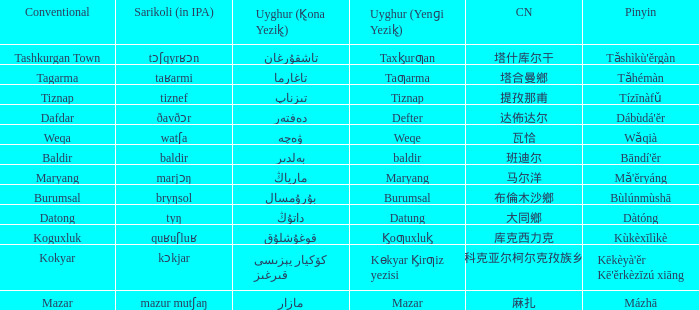Name the uyghur for  瓦恰 ۋەچە. Could you parse the entire table? {'header': ['Conventional', 'Sarikoli (in IPA)', 'Uyghur (K̢ona Yezik̢)', 'Uyghur (Yenɡi Yezik̢)', 'CN', 'Pinyin'], 'rows': [['Tashkurgan Town', 'tɔʃqyrʁɔn', 'تاشقۇرغان', 'Taxk̡urƣan', '塔什库尔干', "Tǎshìkù'ěrgàn"], ['Tagarma', 'taʁarmi', 'تاغارما', 'Taƣarma', '塔合曼鄉', 'Tǎhémàn'], ['Tiznap', 'tiznef', 'تىزناپ', 'Tiznap', '提孜那甫', 'Tízīnàfǔ'], ['Dafdar', 'ðavðɔr', 'دەفتەر', 'Defter', '达佈达尔', "Dábùdá'ĕr"], ['Weqa', 'watʃa', 'ۋەچە', 'Weqe', '瓦恰', 'Wǎqià'], ['Baldir', 'baldir', 'بەلدىر', 'baldir', '班迪尔', "Bāndí'ĕr"], ['Maryang', 'marjɔŋ', 'مارياڭ', 'Maryang', '马尔洋', "Mǎ'ĕryáng"], ['Burumsal', 'bryŋsol', 'بۇرۇمسال', 'Burumsal', '布倫木沙鄉', 'Bùlúnmùshā'], ['Datong', 'tyŋ', 'داتۇڭ', 'Datung', '大同鄉', 'Dàtóng'], ['Koguxluk', 'quʁuʃluʁ', 'قوغۇشلۇق', 'K̡oƣuxluk̡', '库克西力克', 'Kùkèxīlìkè'], ['Kokyar', 'kɔkjar', 'كۆكيار قىرغىز يېزىسى', 'Kɵkyar K̡irƣiz yezisi', '科克亚尔柯尔克孜族乡', "Kēkèyà'ěr Kē'ěrkèzīzú xiāng"], ['Mazar', 'mazur mutʃaŋ', 'مازار', 'Mazar', '麻扎', 'Mázhā']]} 